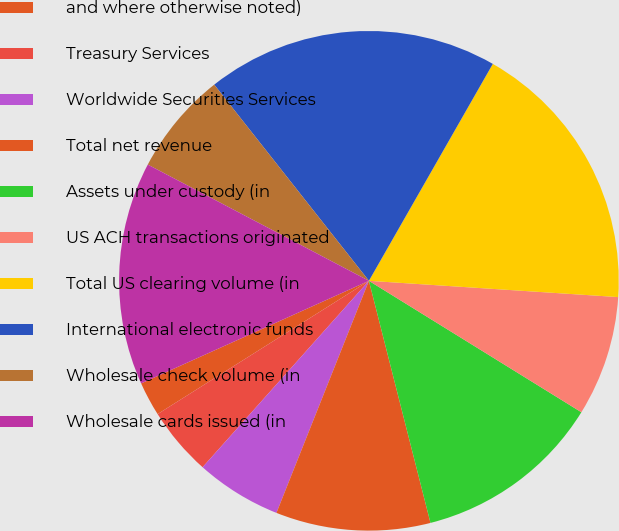Convert chart to OTSL. <chart><loc_0><loc_0><loc_500><loc_500><pie_chart><fcel>and where otherwise noted)<fcel>Treasury Services<fcel>Worldwide Securities Services<fcel>Total net revenue<fcel>Assets under custody (in<fcel>US ACH transactions originated<fcel>Total US clearing volume (in<fcel>International electronic funds<fcel>Wholesale check volume (in<fcel>Wholesale cards issued (in<nl><fcel>2.22%<fcel>4.45%<fcel>5.56%<fcel>10.0%<fcel>12.22%<fcel>7.78%<fcel>17.78%<fcel>18.89%<fcel>6.67%<fcel>14.44%<nl></chart> 